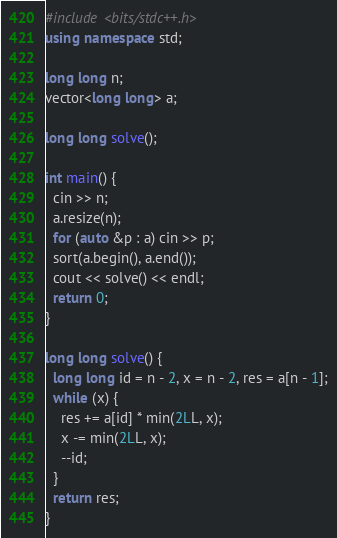<code> <loc_0><loc_0><loc_500><loc_500><_C++_>#include <bits/stdc++.h>
using namespace std;

long long n;
vector<long long> a;

long long solve();

int main() {
  cin >> n;
  a.resize(n);
  for (auto &p : a) cin >> p;
  sort(a.begin(), a.end());
  cout << solve() << endl;
  return 0;
}

long long solve() {
  long long id = n - 2, x = n - 2, res = a[n - 1];
  while (x) {
    res += a[id] * min(2LL, x);
    x -= min(2LL, x);
    --id;
  }
  return res;
}</code> 